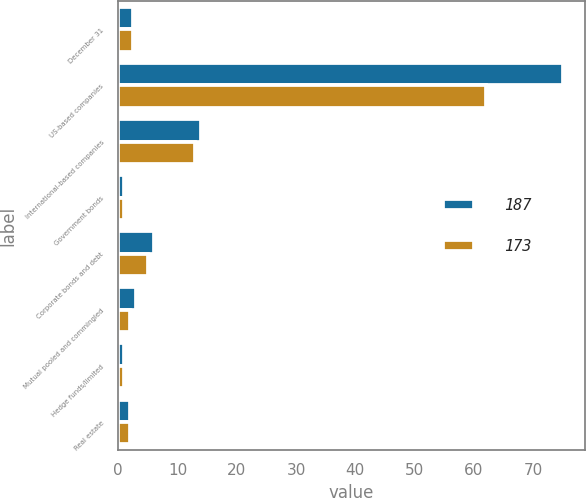Convert chart to OTSL. <chart><loc_0><loc_0><loc_500><loc_500><stacked_bar_chart><ecel><fcel>December 31<fcel>US-based companies<fcel>International-based companies<fcel>Government bonds<fcel>Corporate bonds and debt<fcel>Mutual pooled and commingled<fcel>Hedge funds/limited<fcel>Real estate<nl><fcel>187<fcel>2.5<fcel>75<fcel>14<fcel>1<fcel>6<fcel>3<fcel>1<fcel>2<nl><fcel>173<fcel>2.5<fcel>62<fcel>13<fcel>1<fcel>5<fcel>2<fcel>1<fcel>2<nl></chart> 